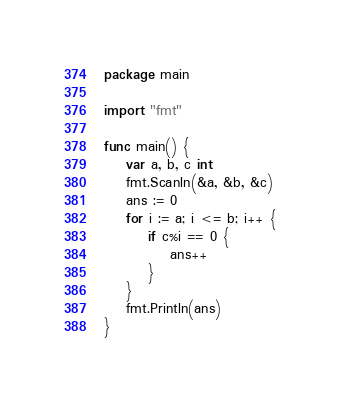<code> <loc_0><loc_0><loc_500><loc_500><_Go_>package main

import "fmt"

func main() {
	var a, b, c int
	fmt.Scanln(&a, &b, &c)
	ans := 0
	for i := a; i <= b; i++ {
		if c%i == 0 {
			ans++
		}
	}
	fmt.Println(ans)
}
</code> 